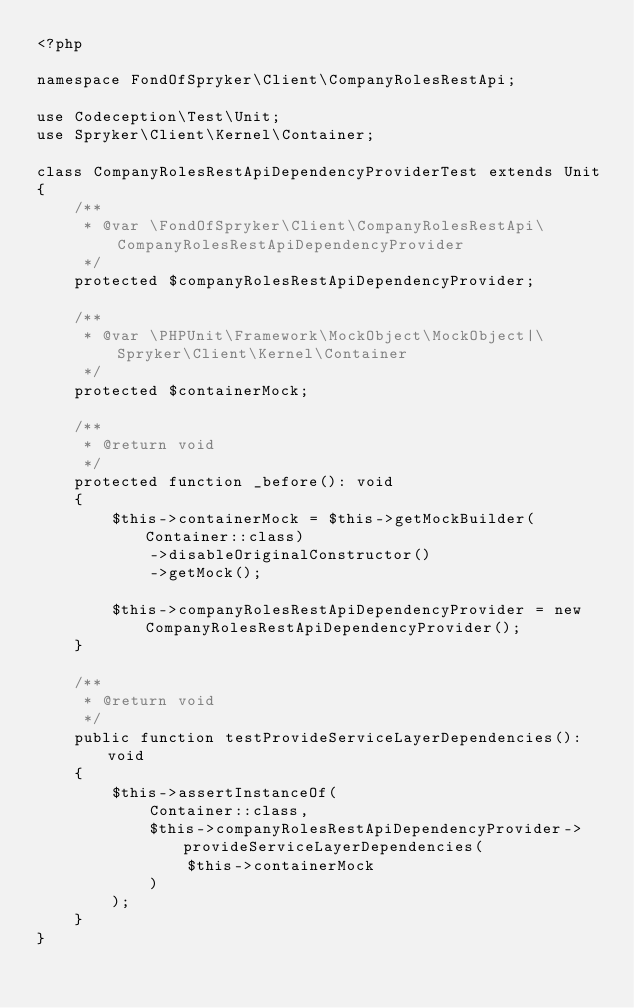Convert code to text. <code><loc_0><loc_0><loc_500><loc_500><_PHP_><?php

namespace FondOfSpryker\Client\CompanyRolesRestApi;

use Codeception\Test\Unit;
use Spryker\Client\Kernel\Container;

class CompanyRolesRestApiDependencyProviderTest extends Unit
{
    /**
     * @var \FondOfSpryker\Client\CompanyRolesRestApi\CompanyRolesRestApiDependencyProvider
     */
    protected $companyRolesRestApiDependencyProvider;

    /**
     * @var \PHPUnit\Framework\MockObject\MockObject|\Spryker\Client\Kernel\Container
     */
    protected $containerMock;

    /**
     * @return void
     */
    protected function _before(): void
    {
        $this->containerMock = $this->getMockBuilder(Container::class)
            ->disableOriginalConstructor()
            ->getMock();

        $this->companyRolesRestApiDependencyProvider = new CompanyRolesRestApiDependencyProvider();
    }

    /**
     * @return void
     */
    public function testProvideServiceLayerDependencies(): void
    {
        $this->assertInstanceOf(
            Container::class,
            $this->companyRolesRestApiDependencyProvider->provideServiceLayerDependencies(
                $this->containerMock
            )
        );
    }
}
</code> 